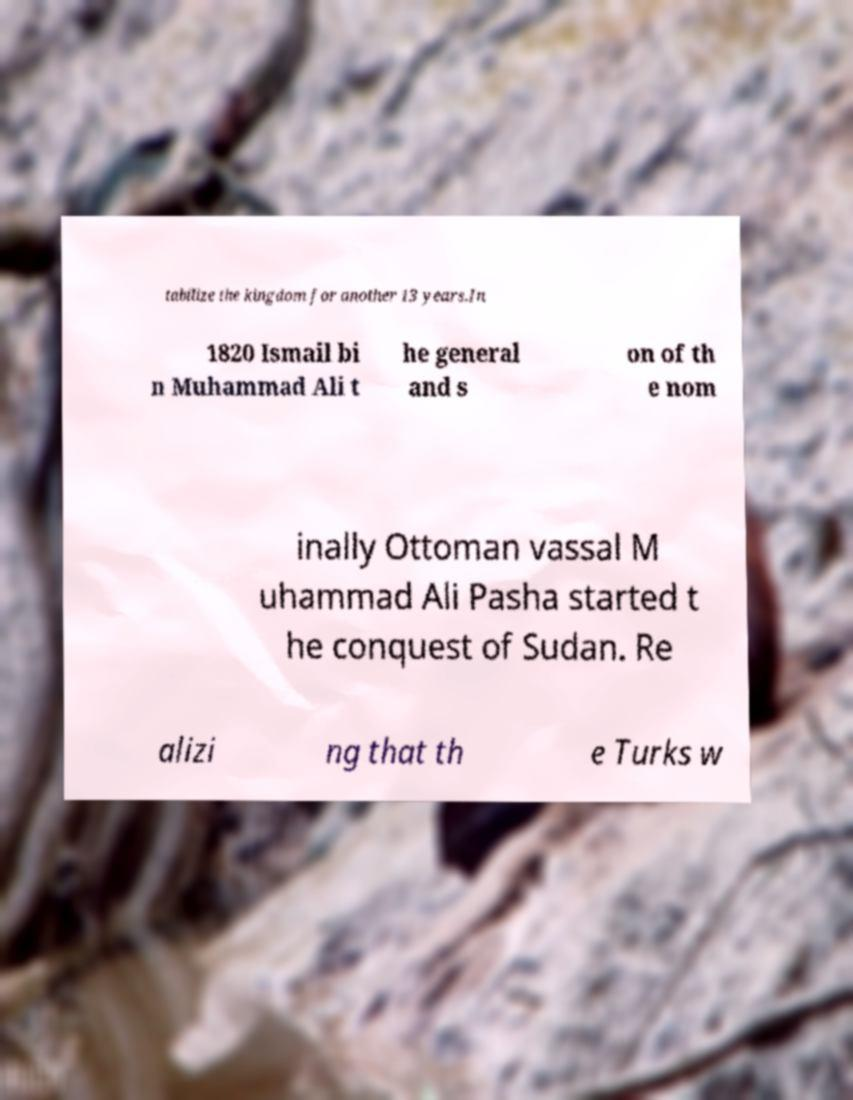Can you accurately transcribe the text from the provided image for me? tabilize the kingdom for another 13 years.In 1820 Ismail bi n Muhammad Ali t he general and s on of th e nom inally Ottoman vassal M uhammad Ali Pasha started t he conquest of Sudan. Re alizi ng that th e Turks w 